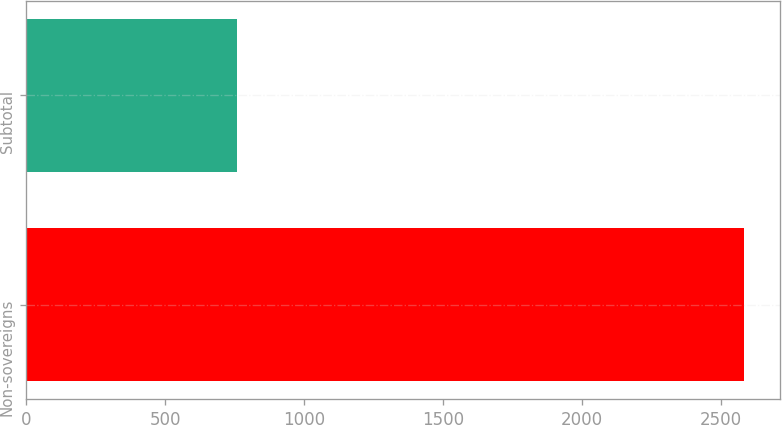Convert chart. <chart><loc_0><loc_0><loc_500><loc_500><bar_chart><fcel>Non-sovereigns<fcel>Subtotal<nl><fcel>2584<fcel>759<nl></chart> 